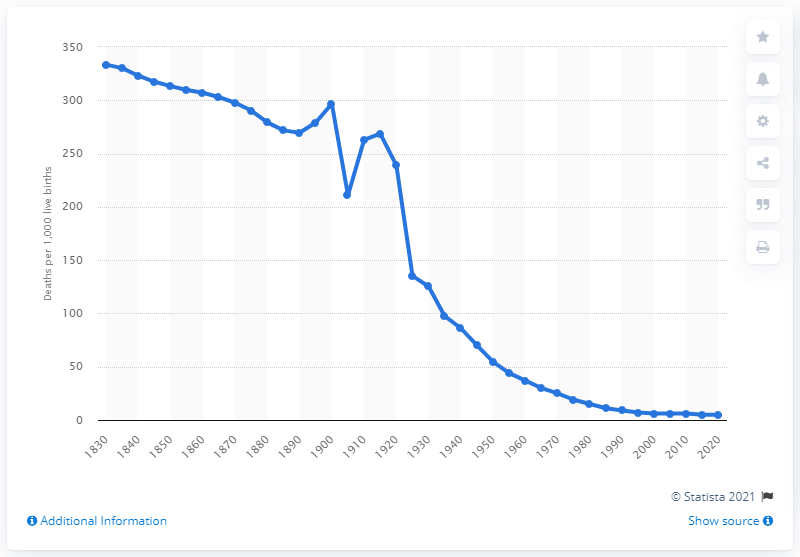Mention a couple of crucial points in this snapshot. The child mortality rate in Canada during the 19th century was 25%. 